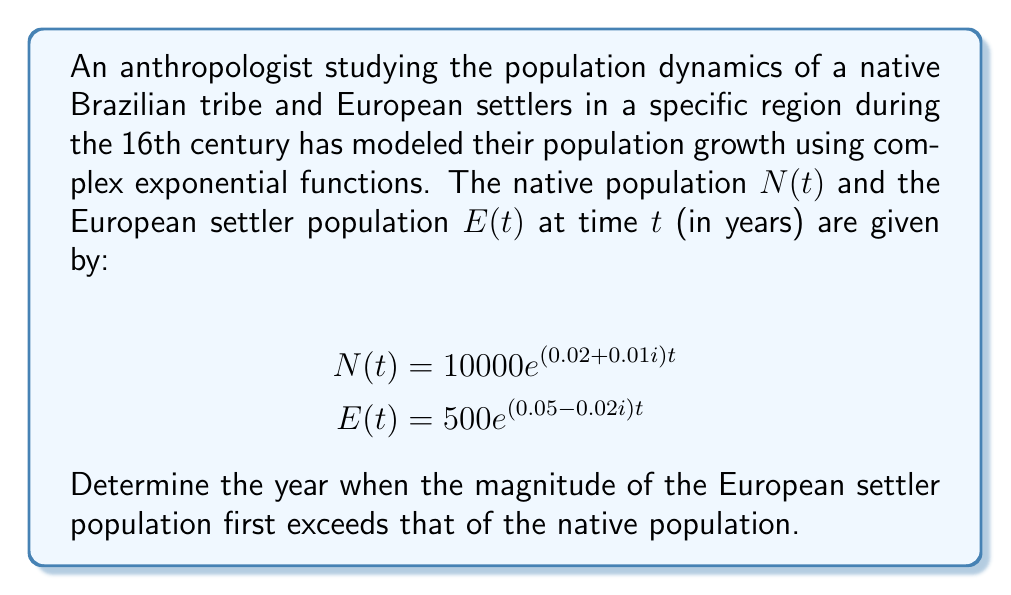Can you answer this question? To solve this problem, we need to find when $|E(t)| > |N(t)|$. Let's approach this step-by-step:

1) For a complex exponential function $ae^{(b+ci)t}$, its magnitude is given by $|ae^{(b+ci)t}| = ae^{bt}$.

2) Therefore, 
   $|N(t)| = 10000e^{0.02t}$
   $|E(t)| = 500e^{0.05t}$

3) We need to solve the equation:
   $500e^{0.05t} = 10000e^{0.02t}$

4) Taking natural logarithm of both sides:
   $\ln(500) + 0.05t = \ln(10000) + 0.02t$

5) Simplify:
   $6.2146 + 0.05t = 9.2103 + 0.02t$

6) Subtract 6.2146 from both sides:
   $0.05t = 2.9957 + 0.02t$

7) Subtract 0.02t from both sides:
   $0.03t = 2.9957$

8) Divide both sides by 0.03:
   $t = 99.86$

9) Since we're looking for the first year when this occurs, we round up to the nearest whole number.
Answer: The European settler population first exceeds the native population in magnitude in the 100th year after the start of the model. 